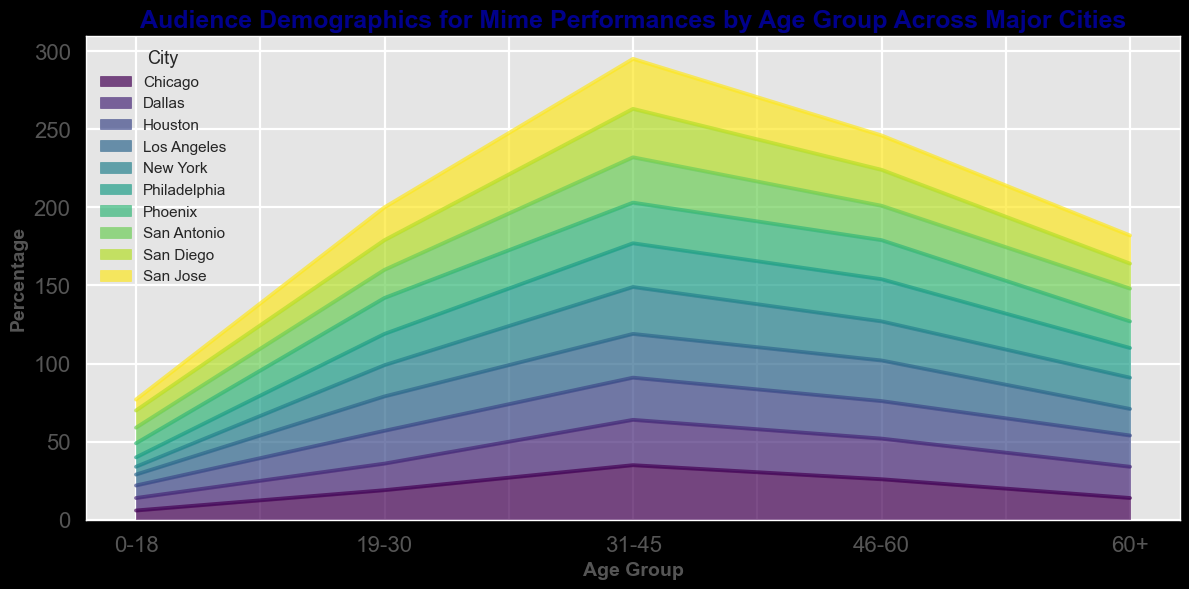Which city has the highest percentage of audience in the 0-18 age group? Look at the heights/colors of the areas for the 0-18 age group across different cities. San Diego has the highest area in the 0-18 age group.
Answer: San Diego In which age group does New York have its highest audience percentage? Look at the heights/colors of the stacked areas for New York across different age groups. The 31-45 age group has the highest area for New York.
Answer: 31-45 Is the audience percentage for the 46-60 age group in Los Angeles greater or less than that in Houston? Compare the heights/colors of the stacked areas for Los Angeles and Houston in the 46-60 age group. Los Angeles has a higher area in the 46-60 age group than Houston.
Answer: Greater What is the combined audience percentage for the 31-45 and 46-60 age groups in Chicago? Add the percentages from the 31-45 and 46-60 age groups in Chicago: 35% (31-45) + 26% (46-60) = 61%.
Answer: 61% Is the audience percentage for the 60+ age group in Philadelphia equal to or different from that in Dallas? Compare the heights/colors of the stacked areas for Philadelphia and Dallas in the 60+ age group. The areas for Philadelphia and Dallas in the 60+ age group are different, with Philadelphia having 19% and Dallas having 20%.
Answer: Different Which city has the smallest audience percentage in the 19-30 age group? Look at the smallest height/color of the areas for the 19-30 age group across different cities. Dallas has the smallest area in the 19-30 age group.
Answer: Dallas How does the audience percentage of the 31-45 age group in San Jose compare to Phoenix? Compare the heights/colors of the areas for the 31-45 age group in San Jose and Phoenix. San Jose has a higher area in the 31-45 age group than Phoenix.
Answer: Higher What is the trend of the audience percentage by age group in New York from youngest to oldest? Observe the height/color of New York's areas from the 0-18 age group to the 60+ age group. The audience percentage starts low in the 0-18 age group, increases, peaks in the 31-45 age group, and then decreases.
Answer: Increases to 31-45, then decreases 